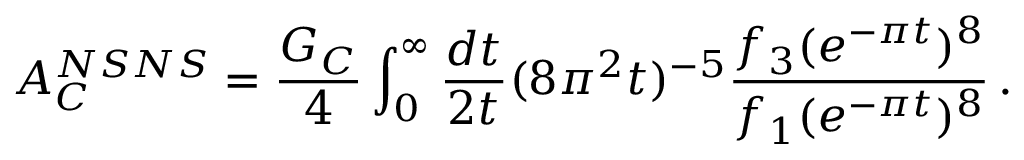Convert formula to latex. <formula><loc_0><loc_0><loc_500><loc_500>A _ { C } ^ { N S N S } = { \frac { G _ { C } } { 4 } } \int _ { 0 } ^ { \infty } { \frac { d t } { 2 t } } ( 8 \pi ^ { 2 } t ) ^ { - 5 } { \frac { f _ { 3 } ( e ^ { - \pi t } ) ^ { 8 } } { f _ { 1 } ( e ^ { - \pi t } ) ^ { 8 } } } \, .</formula> 